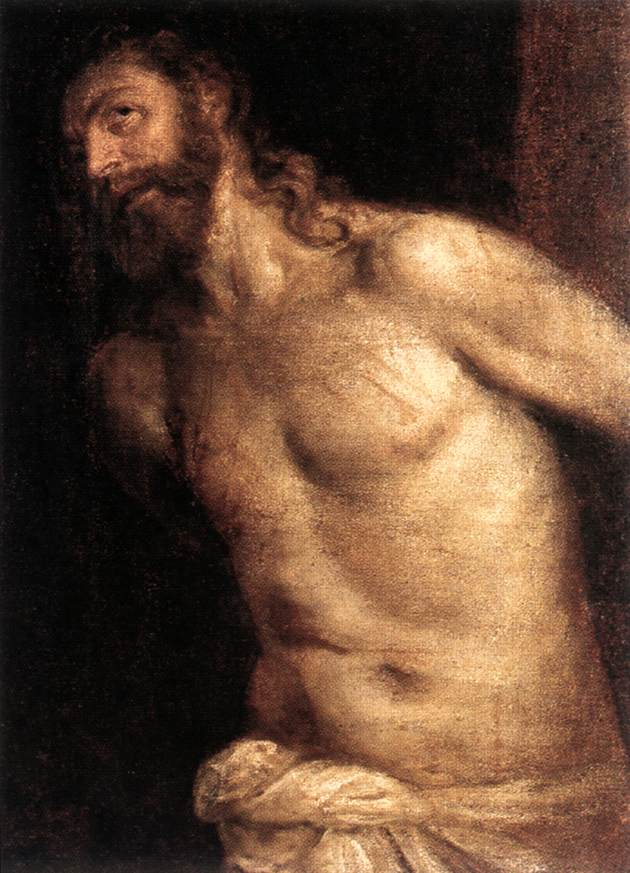What are the key elements in this picture? The painting depicts a bearded man with long flowing hair, embodying a figure that could be interpreted as a biblical character, possibly John the Baptist. It is executed in the Baroque style, notable for its dramatic use of light and shadow, enhancing the three-dimensional form of the figure. The figure's torso is mostly bare, with a white cloth draped over his lower body, emphasizing his muscular physique and contoured lines that catch the light. This light contrast against the dark, undefined background creates a moody atmosphere typical of Caravaggio’s work, inviting the viewer to focus intensely on the subject. The expression on the man's face, looking upward and to the side, suggests contemplation or sorrow, perhaps an indication of his narrative or symbolic significance. 